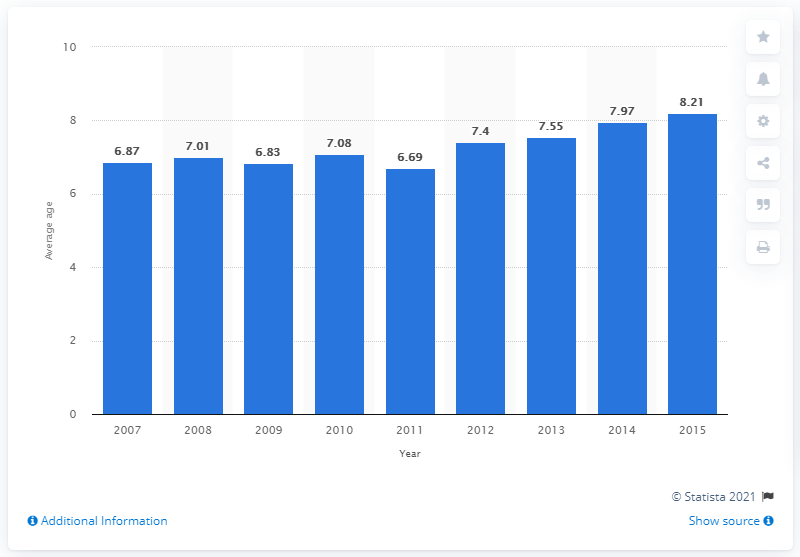List a handful of essential elements in this visual. The value of the bar in 2011 is 6.69. The number of individuals holding onto their older, aging Light Commercial Vehicles (LCVs) began to increase in 2012. The biggest increase in the average age of Light Commercial Vehicles (LCVs) across all years is 0.71 years. 